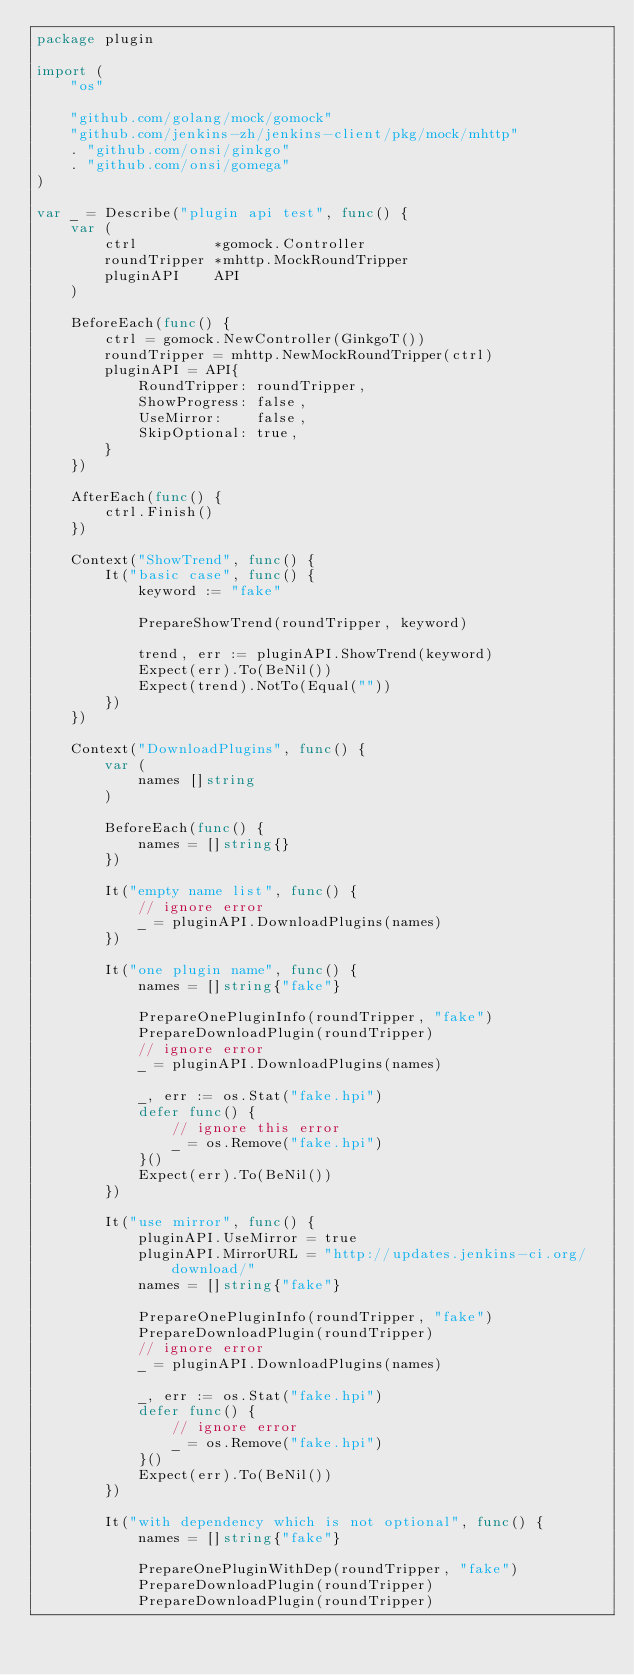Convert code to text. <code><loc_0><loc_0><loc_500><loc_500><_Go_>package plugin

import (
	"os"

	"github.com/golang/mock/gomock"
	"github.com/jenkins-zh/jenkins-client/pkg/mock/mhttp"
	. "github.com/onsi/ginkgo"
	. "github.com/onsi/gomega"
)

var _ = Describe("plugin api test", func() {
	var (
		ctrl         *gomock.Controller
		roundTripper *mhttp.MockRoundTripper
		pluginAPI    API
	)

	BeforeEach(func() {
		ctrl = gomock.NewController(GinkgoT())
		roundTripper = mhttp.NewMockRoundTripper(ctrl)
		pluginAPI = API{
			RoundTripper: roundTripper,
			ShowProgress: false,
			UseMirror:    false,
			SkipOptional: true,
		}
	})

	AfterEach(func() {
		ctrl.Finish()
	})

	Context("ShowTrend", func() {
		It("basic case", func() {
			keyword := "fake"

			PrepareShowTrend(roundTripper, keyword)

			trend, err := pluginAPI.ShowTrend(keyword)
			Expect(err).To(BeNil())
			Expect(trend).NotTo(Equal(""))
		})
	})

	Context("DownloadPlugins", func() {
		var (
			names []string
		)

		BeforeEach(func() {
			names = []string{}
		})

		It("empty name list", func() {
			// ignore error
			_ = pluginAPI.DownloadPlugins(names)
		})

		It("one plugin name", func() {
			names = []string{"fake"}

			PrepareOnePluginInfo(roundTripper, "fake")
			PrepareDownloadPlugin(roundTripper)
			// ignore error
			_ = pluginAPI.DownloadPlugins(names)

			_, err := os.Stat("fake.hpi")
			defer func() {
				// ignore this error
				_ = os.Remove("fake.hpi")
			}()
			Expect(err).To(BeNil())
		})

		It("use mirror", func() {
			pluginAPI.UseMirror = true
			pluginAPI.MirrorURL = "http://updates.jenkins-ci.org/download/"
			names = []string{"fake"}

			PrepareOnePluginInfo(roundTripper, "fake")
			PrepareDownloadPlugin(roundTripper)
			// ignore error
			_ = pluginAPI.DownloadPlugins(names)

			_, err := os.Stat("fake.hpi")
			defer func() {
				// ignore error
				_ = os.Remove("fake.hpi")
			}()
			Expect(err).To(BeNil())
		})

		It("with dependency which is not optional", func() {
			names = []string{"fake"}

			PrepareOnePluginWithDep(roundTripper, "fake")
			PrepareDownloadPlugin(roundTripper)
			PrepareDownloadPlugin(roundTripper)</code> 